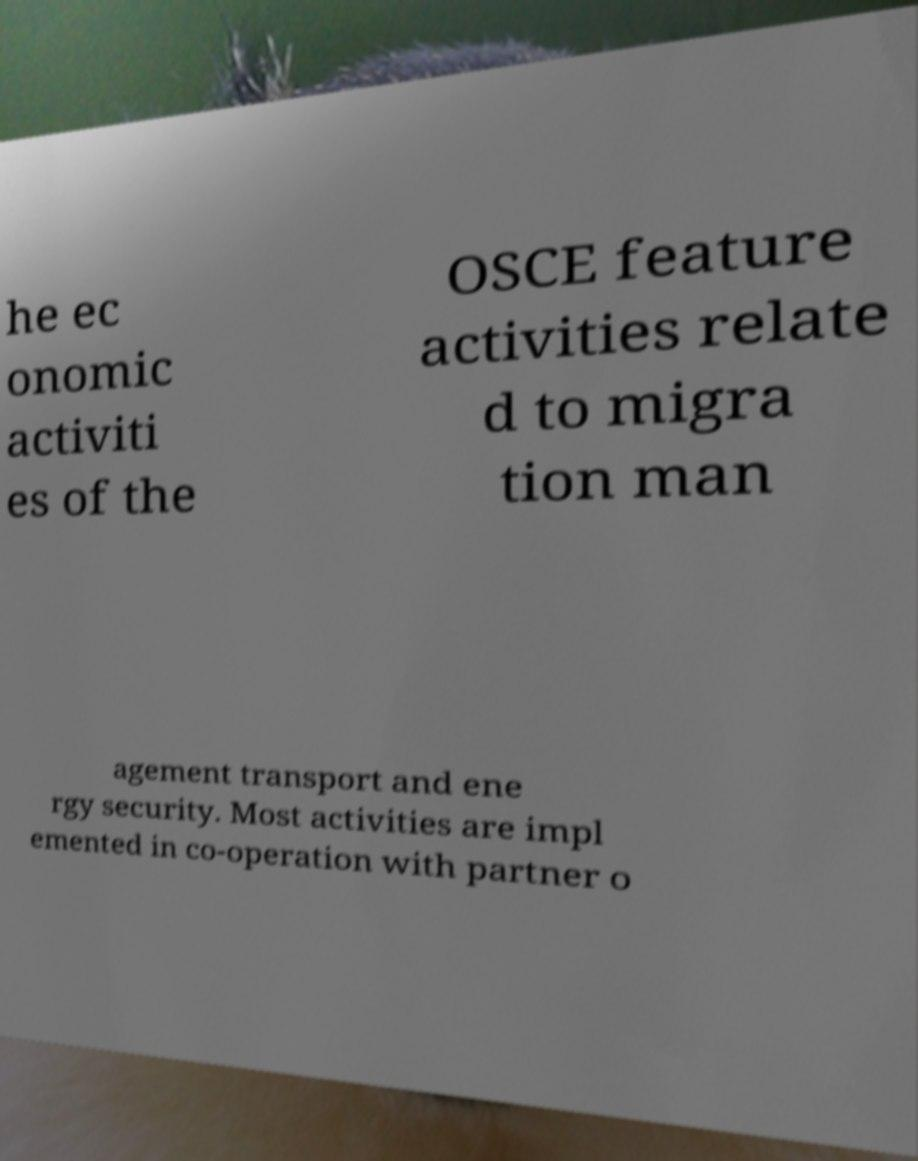Could you extract and type out the text from this image? he ec onomic activiti es of the OSCE feature activities relate d to migra tion man agement transport and ene rgy security. Most activities are impl emented in co-operation with partner o 